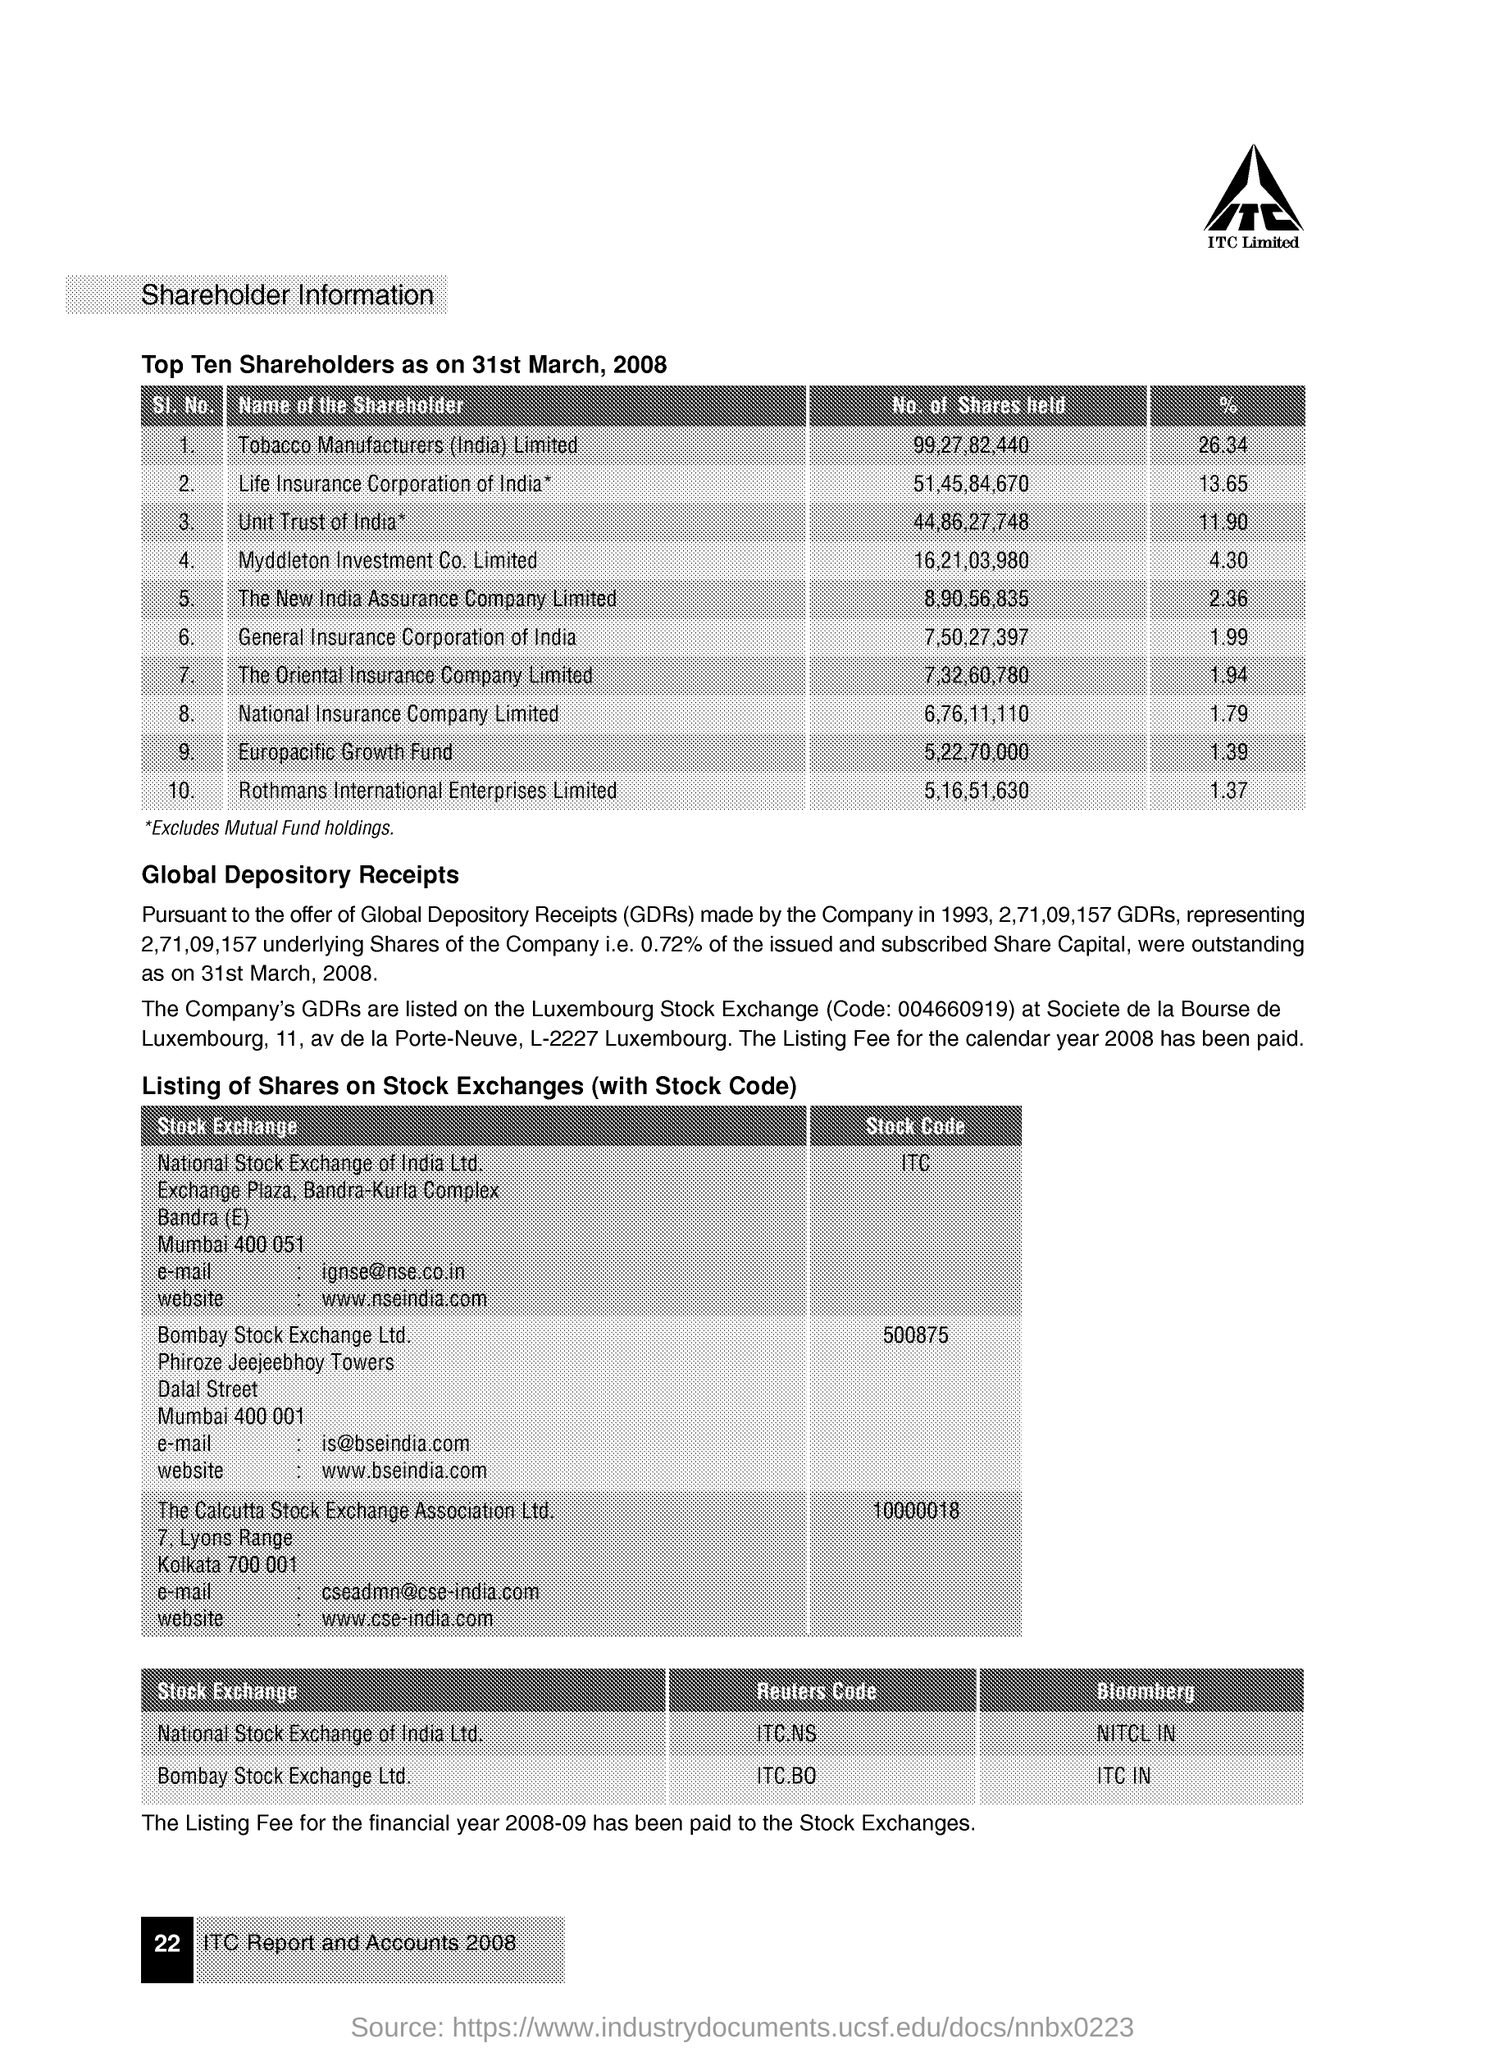Who has the maximum percentage of the shares as on 31st March, 2008?
Your answer should be compact. Tobacco Manufacturers (India) Limited. What percentage of shares does National Insurance Company hold?
Your answer should be compact. 1.79. How many shares are held by Europacific Growth Fund?
Give a very brief answer. 5,22,70,000. What is the Stock Code in Bombay Stock Exchange Ltd.?
Your answer should be very brief. 500875. What is the Reuters Code in National Stock Exchange of India Ltd.?
Offer a very short reply. ITC.NS. 